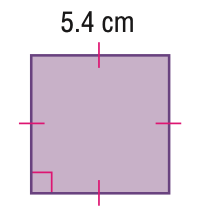Question: Find the area of the parallelogram. Round to the nearest tenth if necessary.
Choices:
A. 10.8
B. 21.6
C. 25
D. 29.2
Answer with the letter. Answer: D 